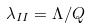Convert formula to latex. <formula><loc_0><loc_0><loc_500><loc_500>\lambda _ { I I } = \Lambda / Q</formula> 